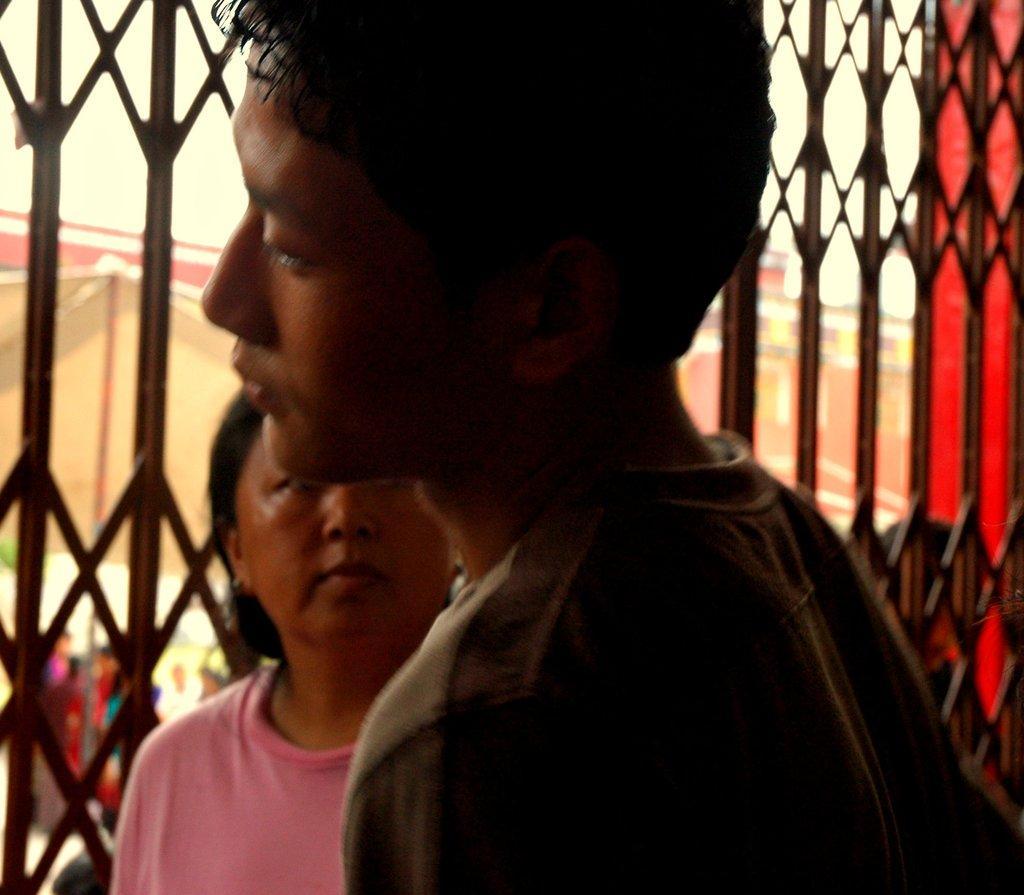Please provide a concise description of this image. In this picture there is a boy in the center of the image and there is a woman behind him and there is a gate in the background area of the image. 